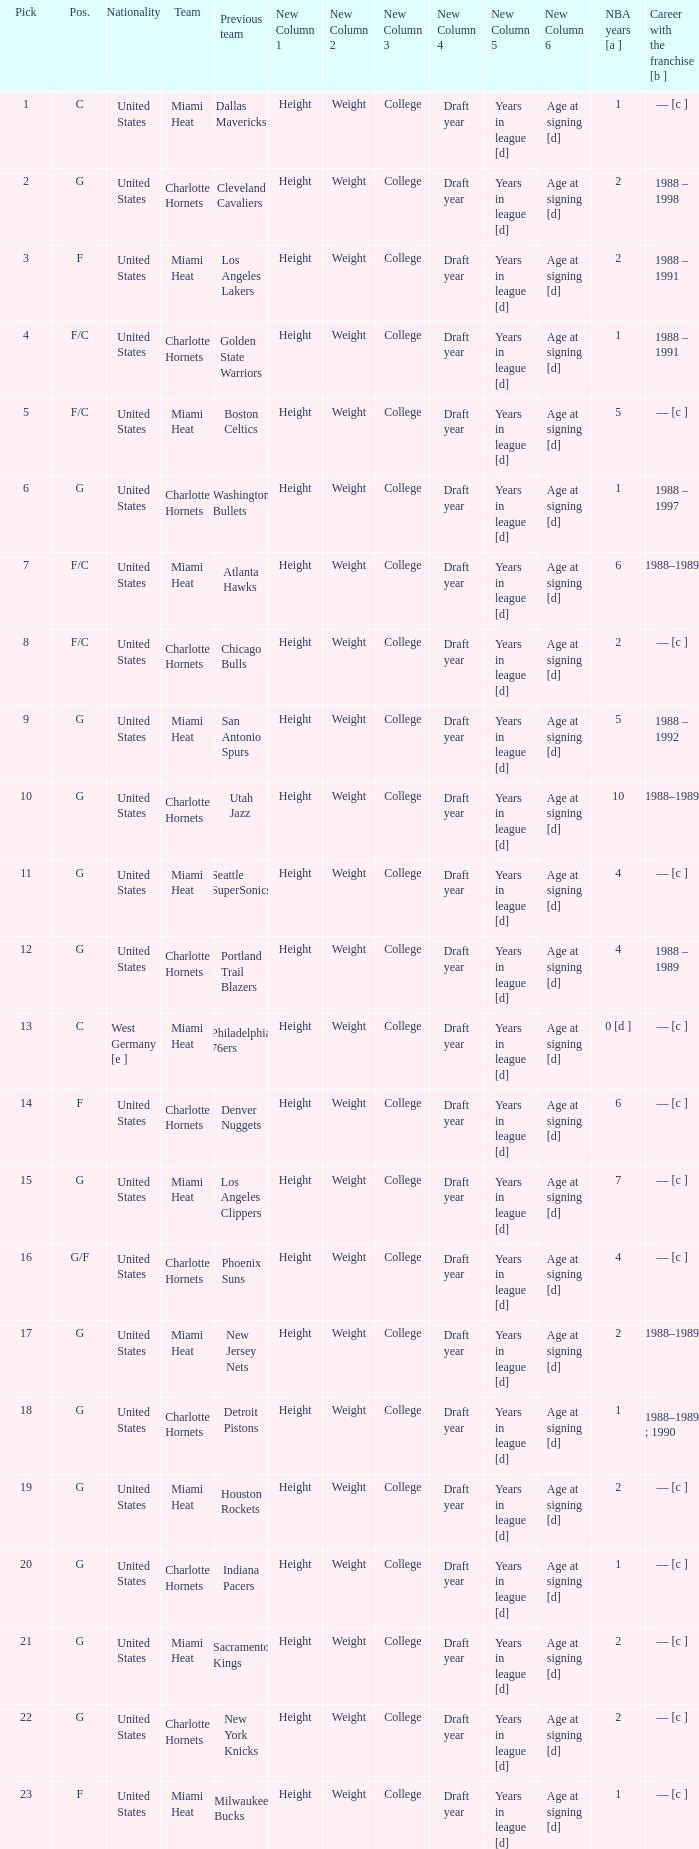How many NBA years did the player from the United States who was previously on the los angeles lakers have? 2.0. 